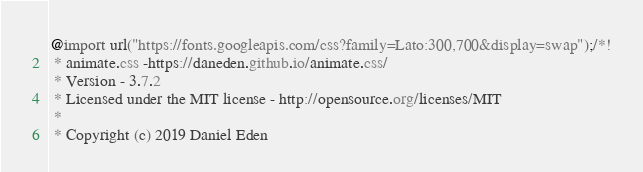Convert code to text. <code><loc_0><loc_0><loc_500><loc_500><_CSS_>@import url("https://fonts.googleapis.com/css?family=Lato:300,700&display=swap");/*!
 * animate.css -https://daneden.github.io/animate.css/
 * Version - 3.7.2
 * Licensed under the MIT license - http://opensource.org/licenses/MIT
 *
 * Copyright (c) 2019 Daniel Eden</code> 